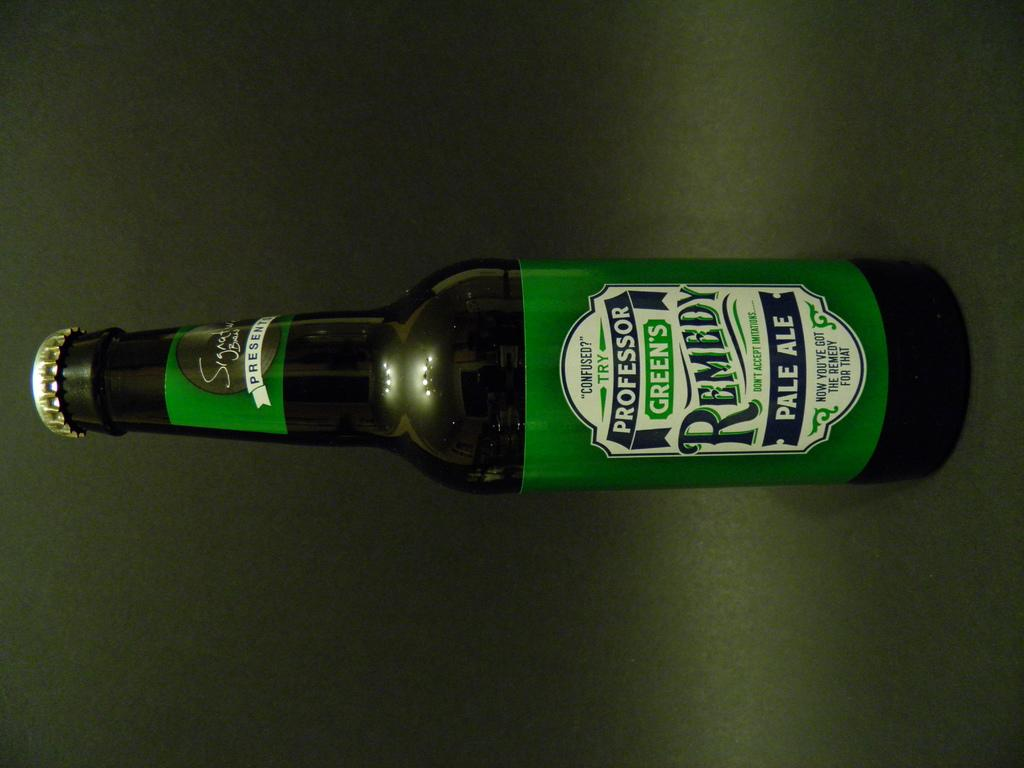What object is present in the image? There is a bottle in the image. What is the color of the surface the bottle is on? The bottle is on a green surface. What can be found on the bottle itself? There is text on the bottle. Can you see a frog jumping on the bottle in the image? No, there is no frog present in the image. What type of wave is visible in the background of the image? There is no wave visible in the image; it only features a bottle on a green surface with text. 